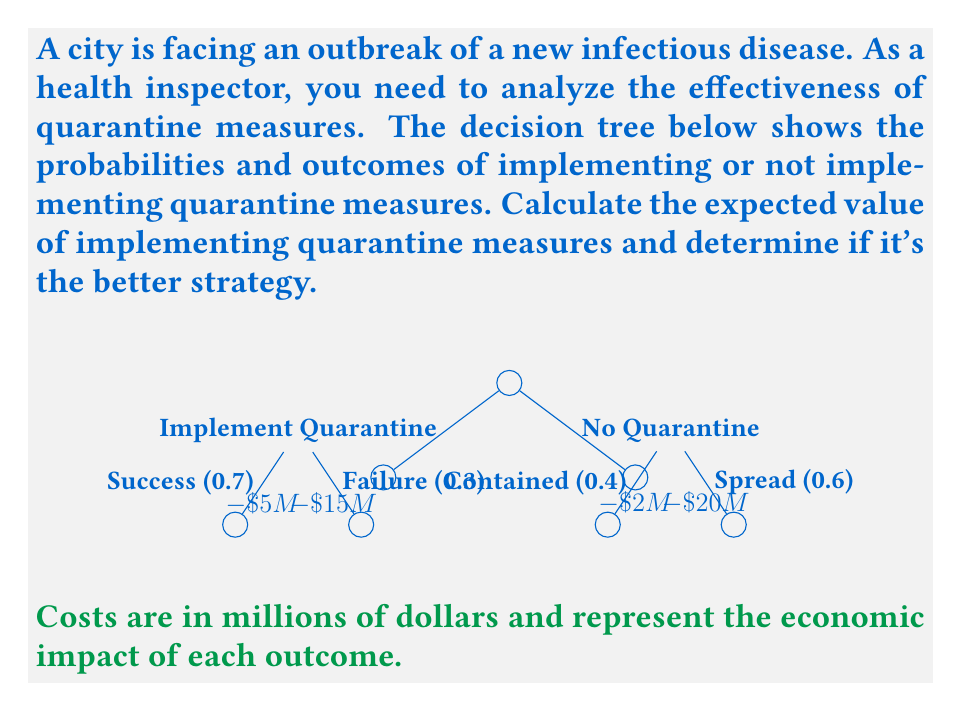What is the answer to this math problem? To solve this problem, we need to calculate the expected value of both strategies (implementing quarantine and not implementing quarantine) and compare them.

1. Expected Value of Implementing Quarantine:

The expected value is calculated by multiplying each outcome by its probability and summing the results.

$$EV(\text{Quarantine}) = 0.7 \times (-\$5M) + 0.3 \times (-\$15M)$$
$$= -\$3.5M - \$4.5M = -\$8M$$

2. Expected Value of Not Implementing Quarantine:

$$EV(\text{No Quarantine}) = 0.4 \times (-\$2M) + 0.6 \times (-\$20M)$$
$$= -\$0.8M - \$12M = -\$12.8M$$

3. Comparison:

The expected value of implementing quarantine measures ($-\$8M$) is higher (less negative) than not implementing quarantine ($-\$12.8M$).

4. Decision:

Based on the expected values, implementing quarantine measures is the better strategy as it results in a lower expected economic impact.

5. Interpretation:

As a health inspector, you would recommend implementing quarantine measures. Although there's a cost associated with quarantine, the potential cost of not containing the outbreak is much higher. The quarantine strategy provides better control over the outbreak and minimizes the expected economic impact.
Answer: The expected value of implementing quarantine measures is $-\$8M$, which is better than the expected value of not implementing quarantine ($-\$12.8M$). Therefore, implementing quarantine measures is the more effective strategy. 